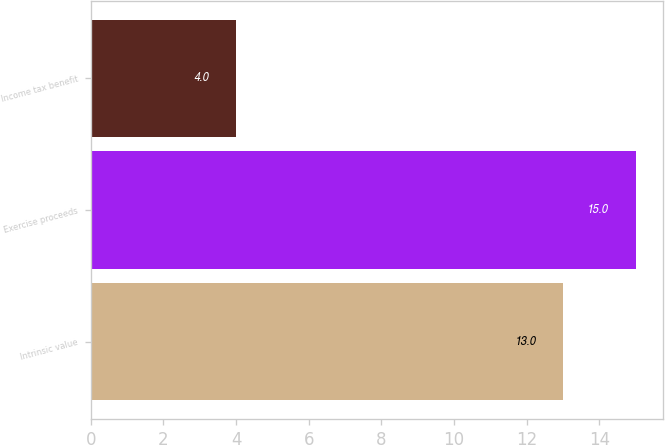Convert chart to OTSL. <chart><loc_0><loc_0><loc_500><loc_500><bar_chart><fcel>Intrinsic value<fcel>Exercise proceeds<fcel>Income tax benefit<nl><fcel>13<fcel>15<fcel>4<nl></chart> 